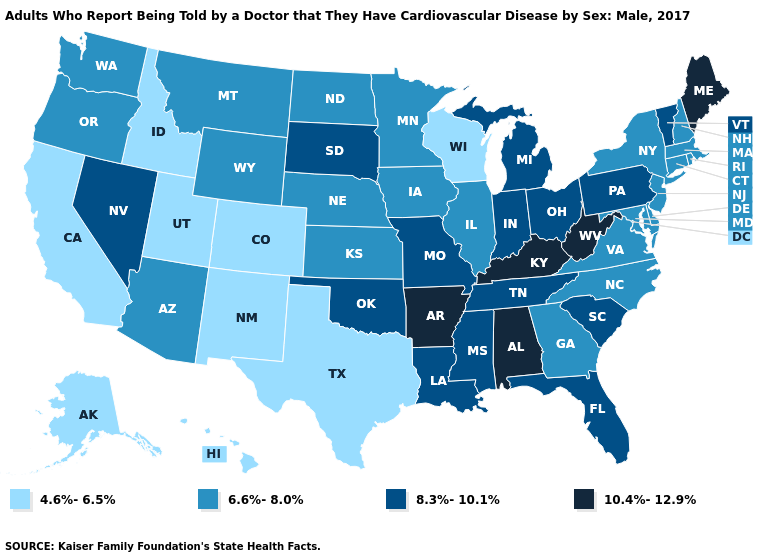What is the highest value in states that border Georgia?
Concise answer only. 10.4%-12.9%. What is the value of Nevada?
Be succinct. 8.3%-10.1%. Name the states that have a value in the range 8.3%-10.1%?
Answer briefly. Florida, Indiana, Louisiana, Michigan, Mississippi, Missouri, Nevada, Ohio, Oklahoma, Pennsylvania, South Carolina, South Dakota, Tennessee, Vermont. What is the value of Pennsylvania?
Keep it brief. 8.3%-10.1%. Does the map have missing data?
Write a very short answer. No. What is the highest value in states that border Delaware?
Quick response, please. 8.3%-10.1%. Does the map have missing data?
Write a very short answer. No. What is the value of North Carolina?
Answer briefly. 6.6%-8.0%. What is the value of Delaware?
Answer briefly. 6.6%-8.0%. Among the states that border Colorado , which have the highest value?
Concise answer only. Oklahoma. What is the value of Maine?
Be succinct. 10.4%-12.9%. Does the map have missing data?
Short answer required. No. What is the value of New Mexico?
Answer briefly. 4.6%-6.5%. What is the value of Michigan?
Keep it brief. 8.3%-10.1%. Which states have the lowest value in the West?
Keep it brief. Alaska, California, Colorado, Hawaii, Idaho, New Mexico, Utah. 